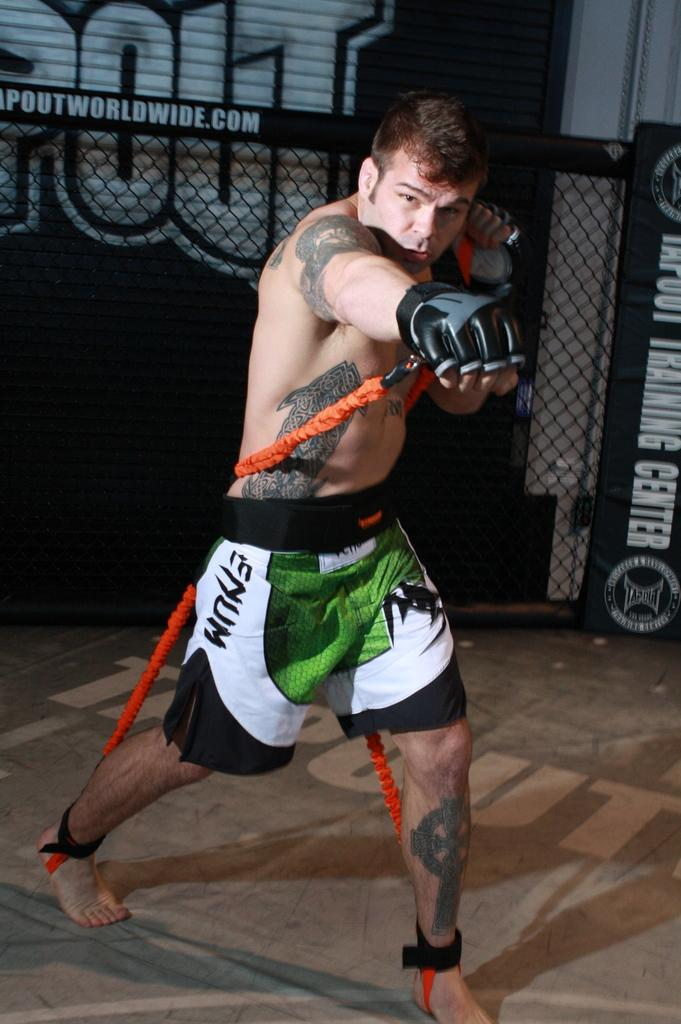<image>
Write a terse but informative summary of the picture. A MMA fighter with green Enum shorts on trains in the ring. 